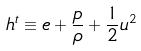<formula> <loc_0><loc_0><loc_500><loc_500>h ^ { t } \equiv e + \frac { p } { \rho } + \frac { 1 } { 2 } u ^ { 2 }</formula> 